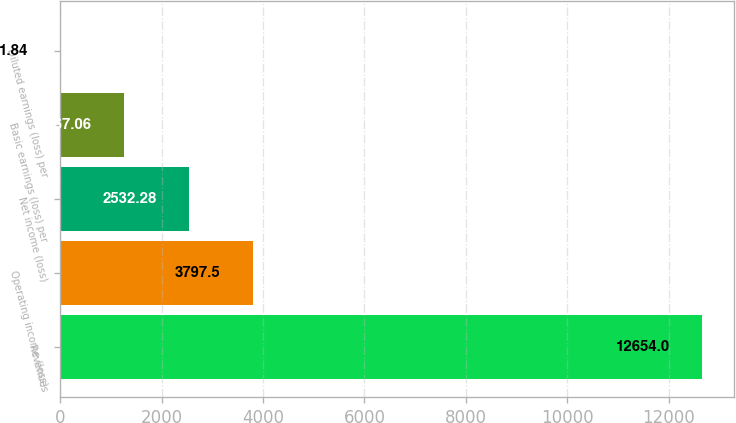Convert chart to OTSL. <chart><loc_0><loc_0><loc_500><loc_500><bar_chart><fcel>Revenues<fcel>Operating income (loss)<fcel>Net income (loss)<fcel>Basic earnings (loss) per<fcel>Diluted earnings (loss) per<nl><fcel>12654<fcel>3797.5<fcel>2532.28<fcel>1267.06<fcel>1.84<nl></chart> 